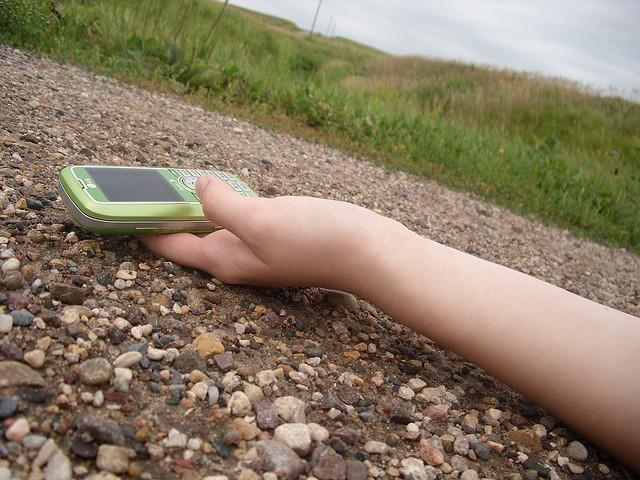What type of phone is in this picture?
Be succinct. Lg. Is this person's phone exposed to the elements?
Concise answer only. Yes. Is there grass in the image?
Quick response, please. Yes. 